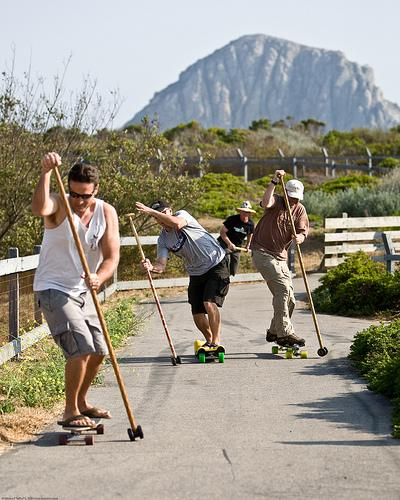Question: where are the shrubs?
Choices:
A. To the right of the path.
B. Outside.
C. In the park.
D. By the tree.
Answer with the letter. Answer: A Question: how many people are there?
Choices:
A. Eight.
B. Nine.
C. Four.
D. Five.
Answer with the letter. Answer: C Question: where is the man in black?
Choices:
A. Inside.
B. At the bus stop.
C. In the back.
D. In the car.
Answer with the letter. Answer: C Question: how many skateboards are visible?
Choices:
A. Four.
B. Three.
C. Nine.
D. Eleven.
Answer with the letter. Answer: B Question: how many hats are there?
Choices:
A. Three.
B. Five.
C. Eight.
D. Eleven.
Answer with the letter. Answer: A 